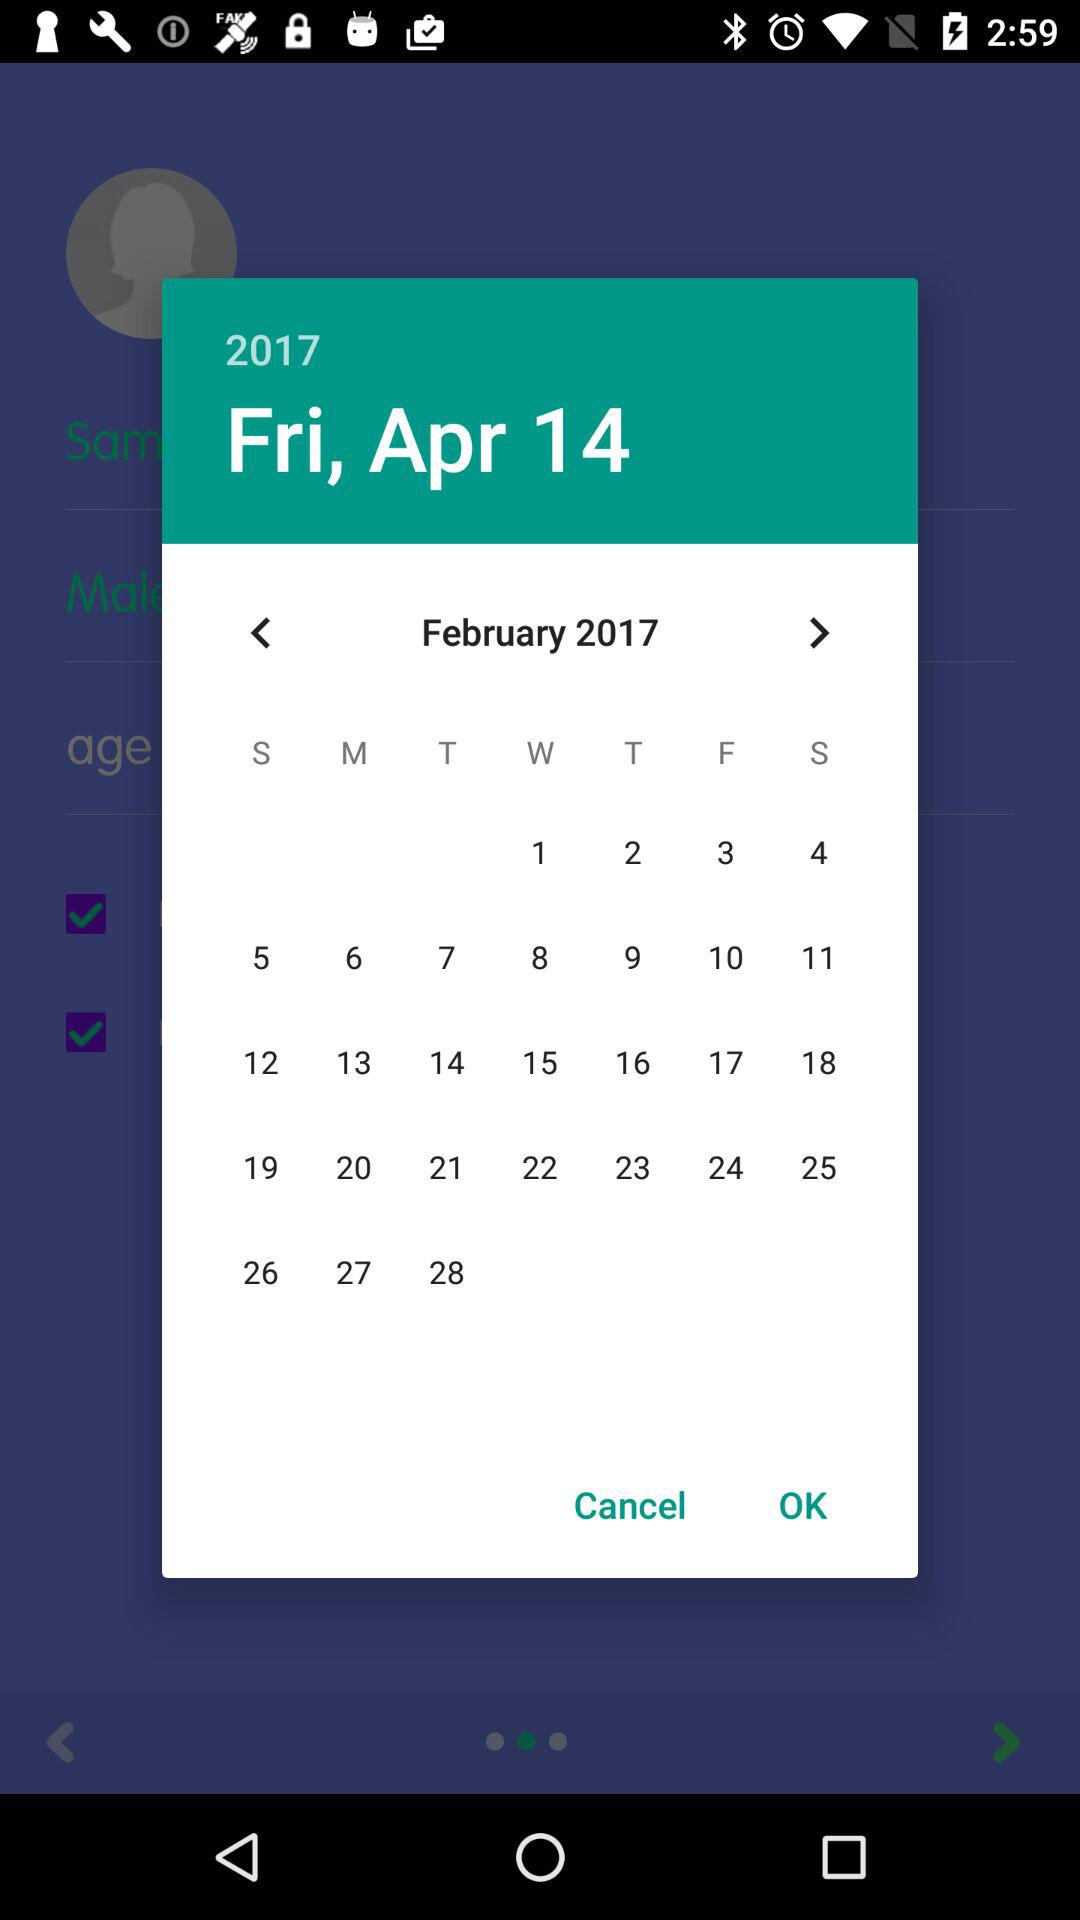What is the day? The day is Friday. 